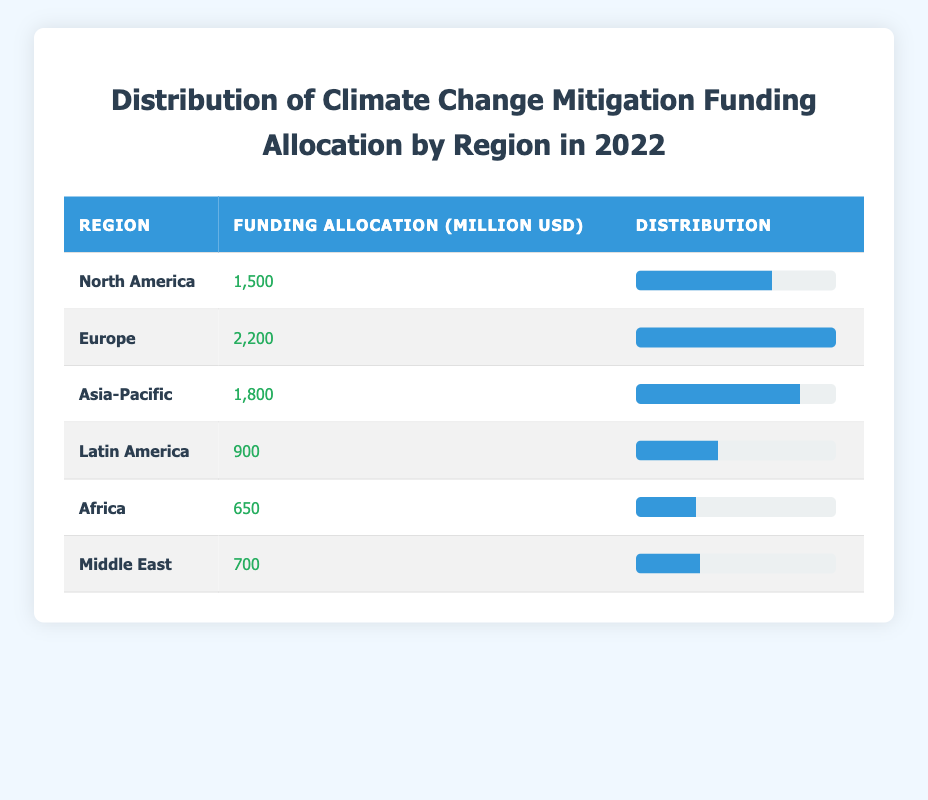What was the total funding allocation for all regions combined in 2022? To find the total funding allocation, we sum the funding allocations for all the regions: 1500 + 2200 + 1800 + 900 + 650 + 700 = 9500 million USD.
Answer: 9500 million USD Which region received the highest funding allocation in 2022? By comparing the funding allocations for each region, Europe received the highest allocation at 2200 million USD.
Answer: Europe Is the funding allocation for Asia-Pacific greater than both Africa and the Middle East combined? The funding allocation for Asia-Pacific is 1800 million USD. The combined funding for Africa and the Middle East is 650 + 700 = 1350 million USD. Since 1800 > 1350, the statement is true.
Answer: Yes What is the average funding allocation for all regions listed? To calculate the average, we first find the total funding (9500 million USD) and then divide by the number of regions (6): 9500 / 6 = 1583.33 million USD.
Answer: 1583.33 million USD Is the funding allocation for North America more than 40% of the total allocation? North America's allocation is 1500 million USD. We calculate the percentage of total funding: (1500 / 9500) * 100 = 15.79%. Since 15.79% is less than 40%, the answer is false.
Answer: No What is the difference in funding allocation between Europe and Latin America? The funding allocation for Europe is 2200 million USD and for Latin America, it is 900 million USD. The difference is 2200 - 900 = 1300 million USD.
Answer: 1300 million USD Which two regions combined received approximately 90% of the total funding allocation? North America (1500 million USD) and Europe (2200 million USD) together received 1500 + 2200 = 3700 million USD. This is much lower than 90% of the total (in this case, 90% would be 8550 million USD), so we need to check combinations. The best combination is Europe (2200 million USD) and Asia-Pacific (1800 million USD), which together give 2200 + 1800 = 4000 million USD (around 42.1% of total funding). This shows combining North America and Europe is the closest approach to achieving 90% yet, alone they do not.
Answer: No Is Asia-Pacific's funding allocation less than the average? The average funding allocation is 1583.33 million USD, and Asia-Pacific received 1800 million USD. Since 1800 is greater than the average, the statement is false.
Answer: No 